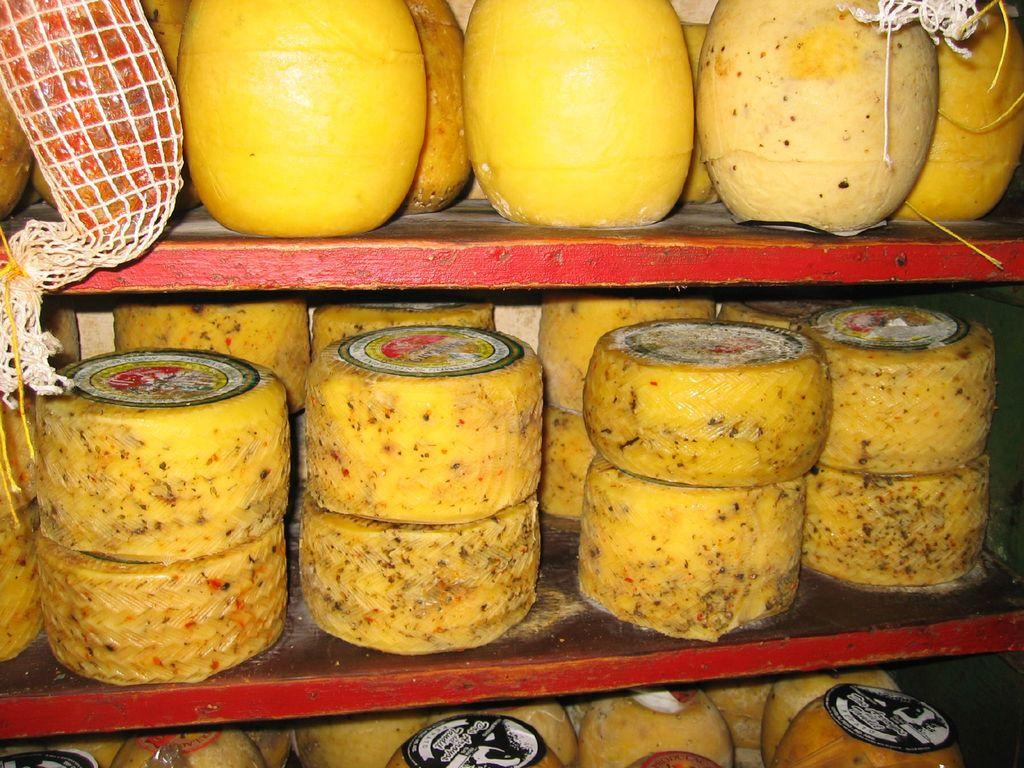What type of food can be seen in the image? There are cheese blocks in the image. Are there any additional features on the cheese blocks? Yes, the cheese blocks have stickers on them. Where are the cheese blocks located? The cheese blocks are placed on a shelf. What type of shop can be seen in the image? There is no shop present in the image; it only features cheese blocks with stickers on a shelf. How are the cheese blocks being used to support the crackers in the image? There are no crackers present in the image, so the cheese blocks are not being used to support them. 